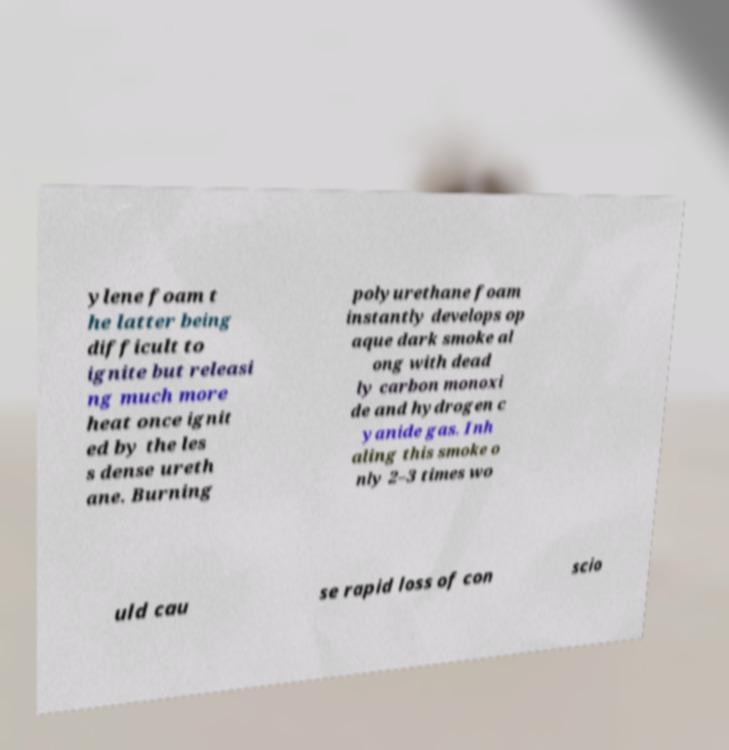Please read and relay the text visible in this image. What does it say? ylene foam t he latter being difficult to ignite but releasi ng much more heat once ignit ed by the les s dense ureth ane. Burning polyurethane foam instantly develops op aque dark smoke al ong with dead ly carbon monoxi de and hydrogen c yanide gas. Inh aling this smoke o nly 2–3 times wo uld cau se rapid loss of con scio 